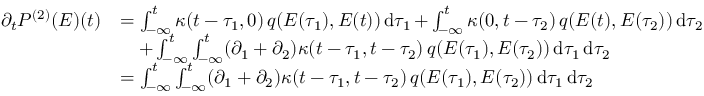<formula> <loc_0><loc_0><loc_500><loc_500>\begin{array} { r l } { \partial _ { t } P ^ { ( 2 ) } ( E ) ( t ) } & { = \int _ { - \infty } ^ { t } \kappa ( t - \tau _ { 1 } , 0 ) \, q ( E ( \tau _ { 1 } ) , E ( t ) ) d \tau _ { 1 } + \int _ { - \infty } ^ { t } \kappa ( 0 , t - \tau _ { 2 } ) \, q ( E ( t ) , E ( \tau _ { 2 } ) ) d \tau _ { 2 } } \\ & { \quad + \int _ { - \infty } ^ { t } \int _ { - \infty } ^ { t } ( \partial _ { 1 } + \partial _ { 2 } ) \kappa ( t - \tau _ { 1 } , t - \tau _ { 2 } ) \, q ( E ( \tau _ { 1 } ) , E ( \tau _ { 2 } ) ) d \tau _ { 1 } d \tau _ { 2 } } \\ & { = \int _ { - \infty } ^ { t } \int _ { - \infty } ^ { t } ( \partial _ { 1 } + \partial _ { 2 } ) \kappa ( t - \tau _ { 1 } , t - \tau _ { 2 } ) \, q ( E ( \tau _ { 1 } ) , E ( \tau _ { 2 } ) ) d \tau _ { 1 } d \tau _ { 2 } } \end{array}</formula> 